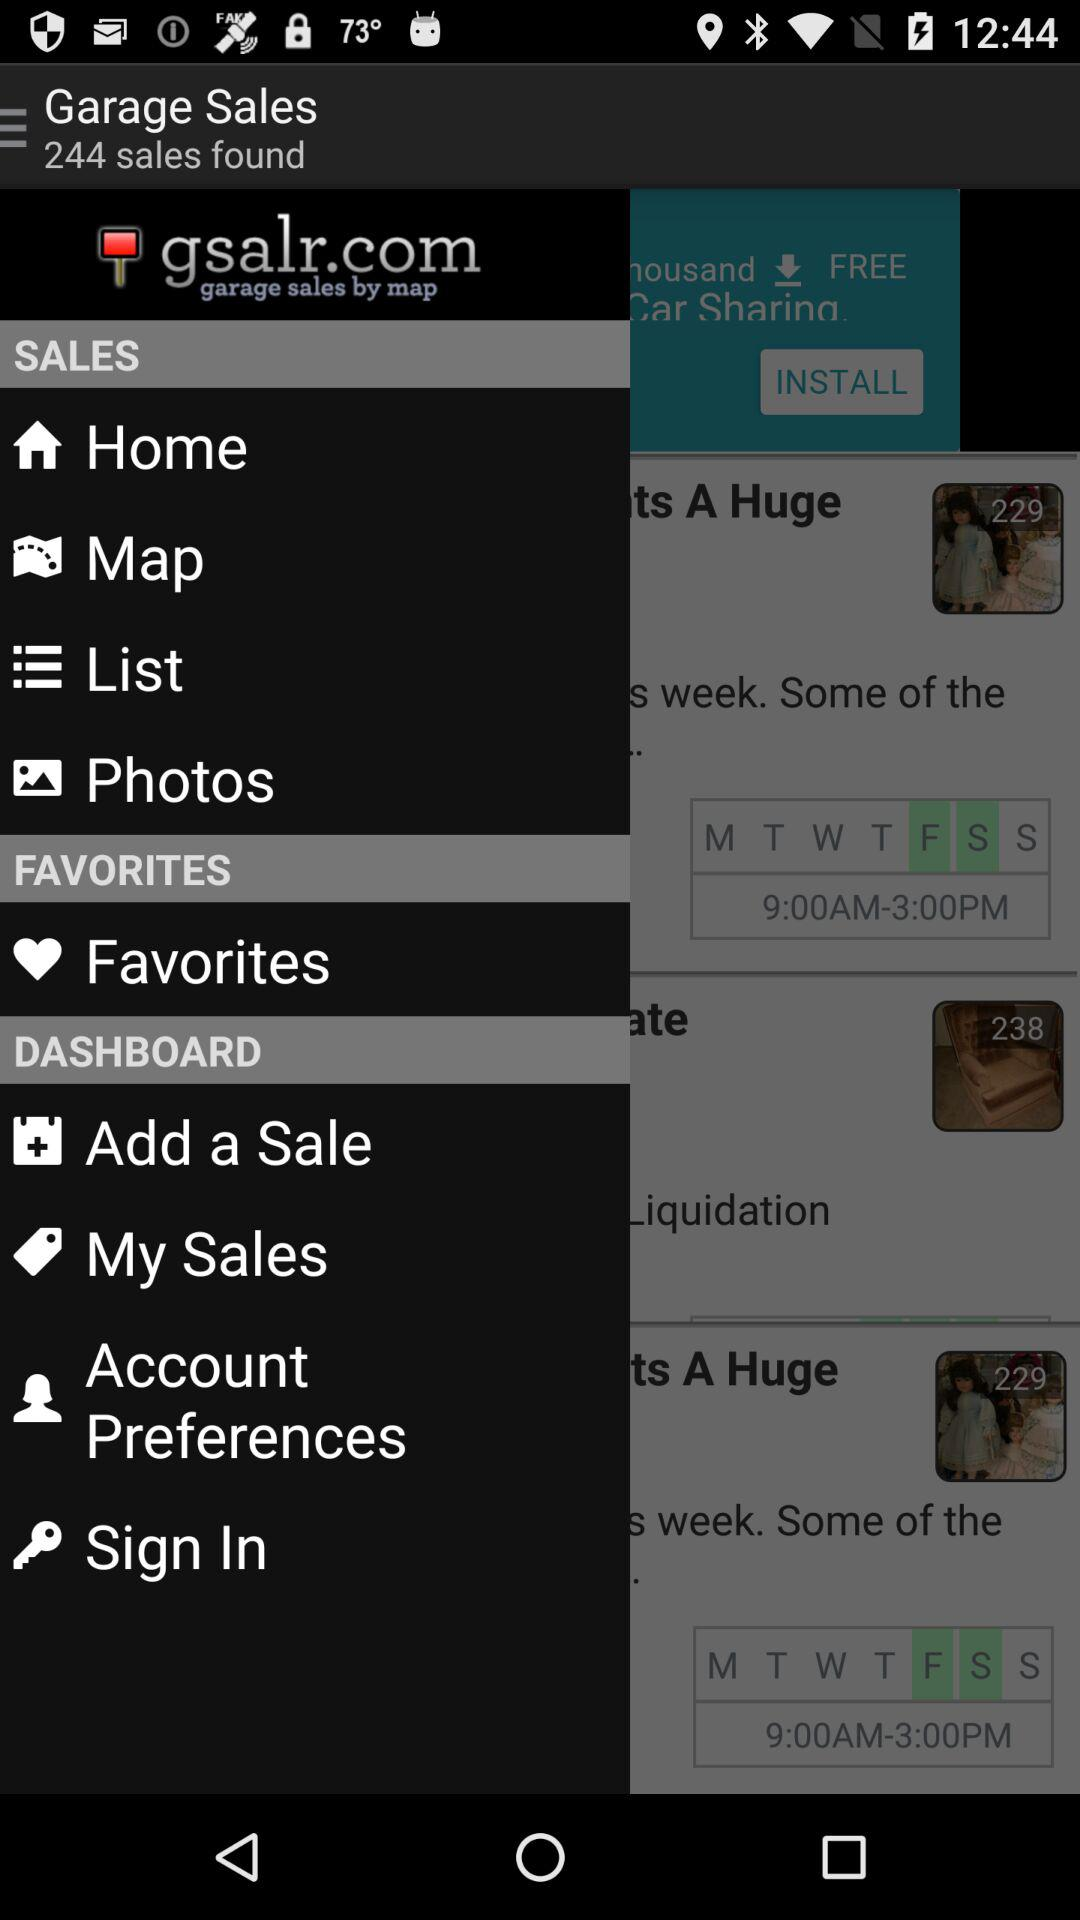What's the total number of sales found? The total number of sales found is 244. 